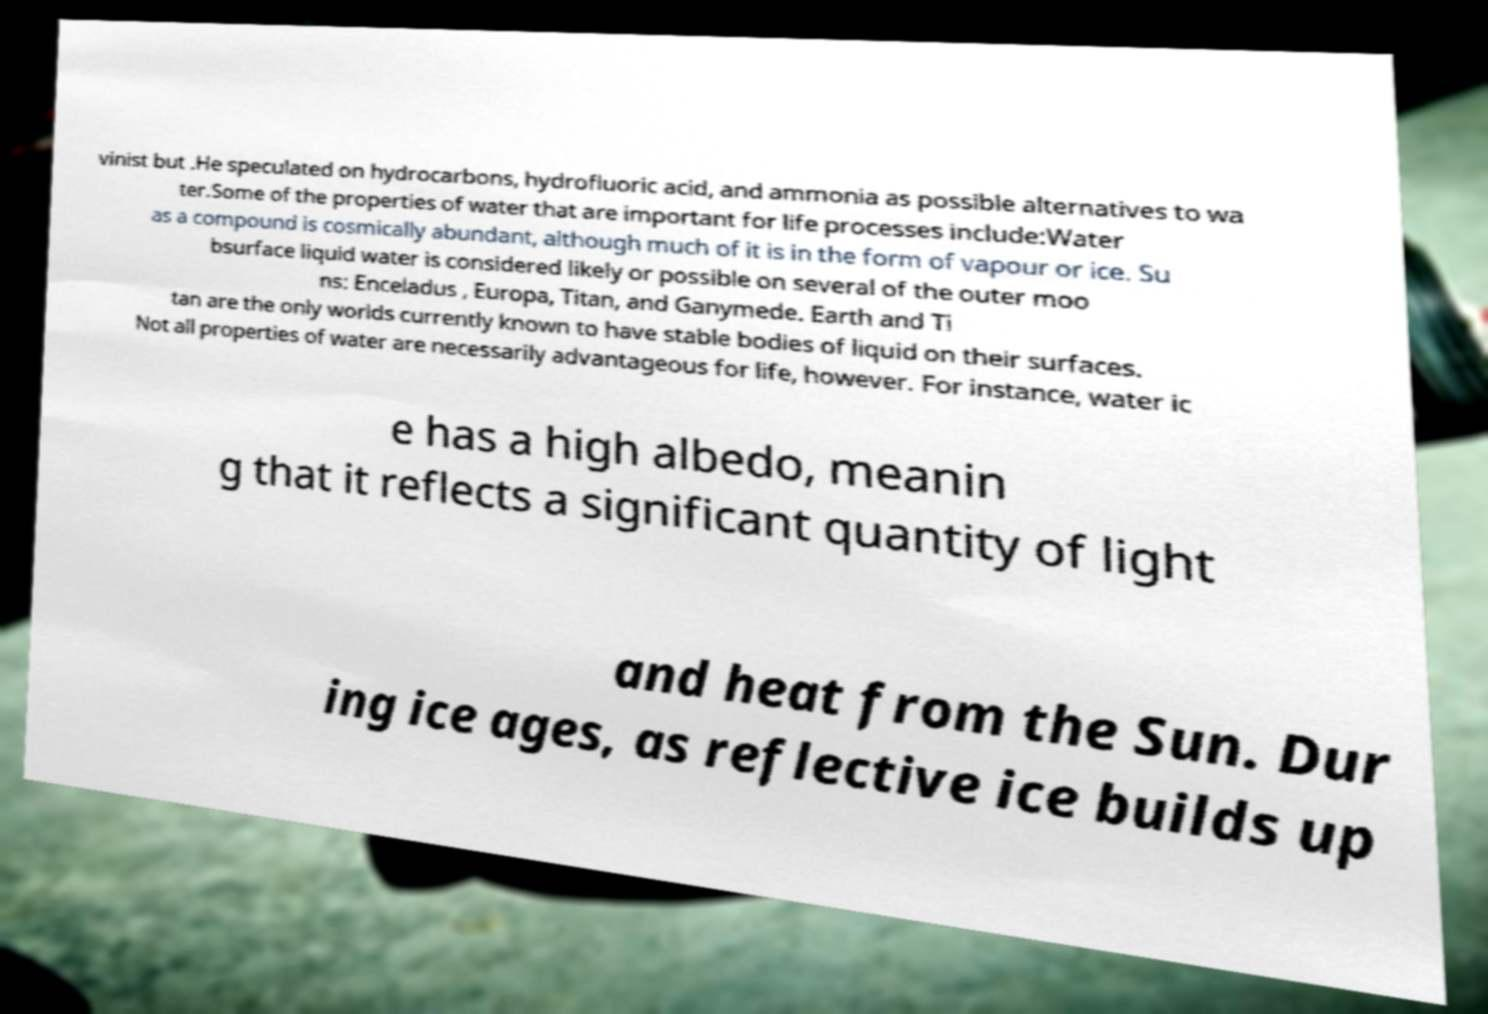What messages or text are displayed in this image? I need them in a readable, typed format. vinist but .He speculated on hydrocarbons, hydrofluoric acid, and ammonia as possible alternatives to wa ter.Some of the properties of water that are important for life processes include:Water as a compound is cosmically abundant, although much of it is in the form of vapour or ice. Su bsurface liquid water is considered likely or possible on several of the outer moo ns: Enceladus , Europa, Titan, and Ganymede. Earth and Ti tan are the only worlds currently known to have stable bodies of liquid on their surfaces. Not all properties of water are necessarily advantageous for life, however. For instance, water ic e has a high albedo, meanin g that it reflects a significant quantity of light and heat from the Sun. Dur ing ice ages, as reflective ice builds up 